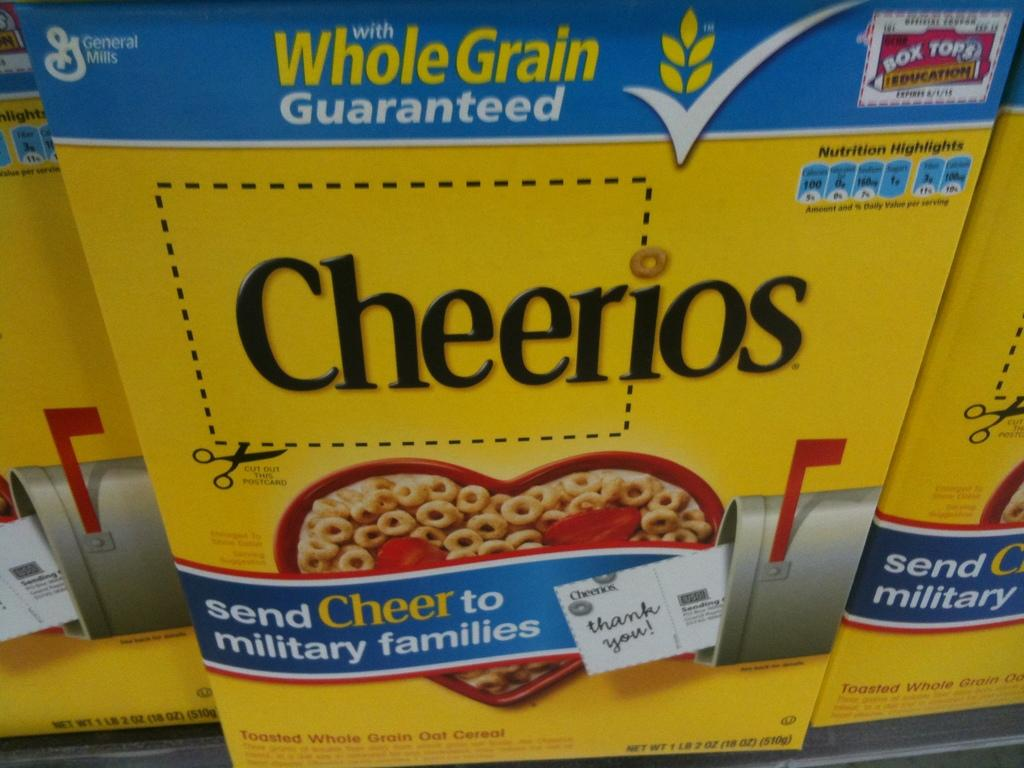<image>
Offer a succinct explanation of the picture presented. Cheerios is asking people to send cheer to military families. 